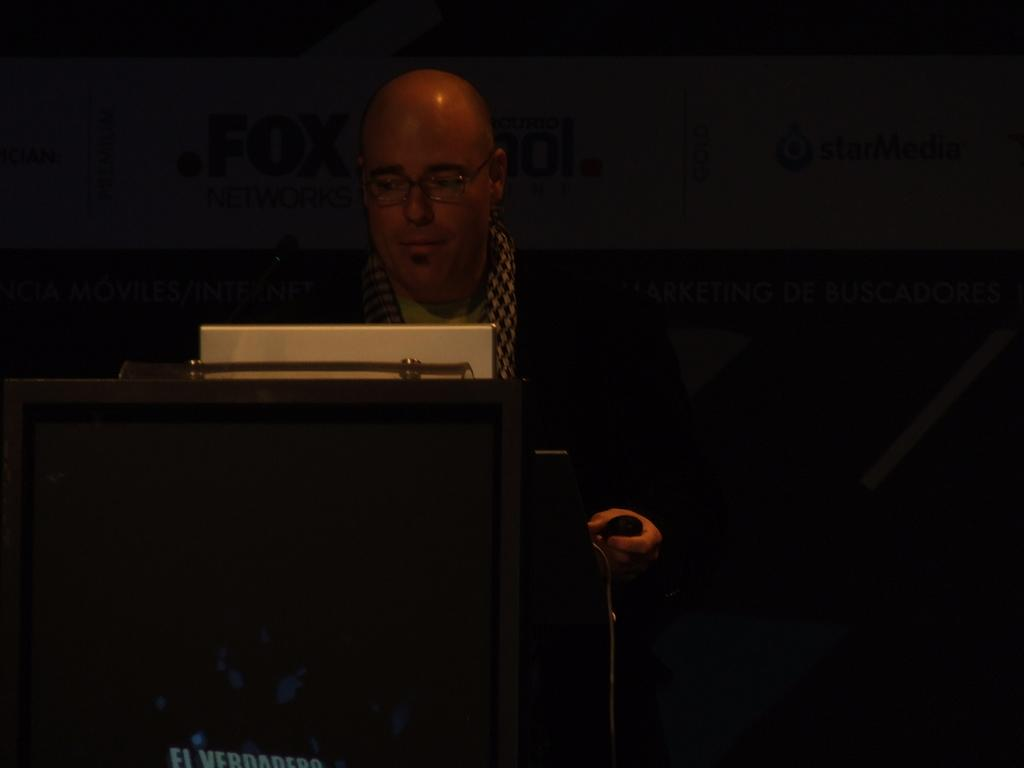What can be seen on the person's face in the image? There is a person with eyeglasses in the image. What is located in front of the person? There is an object in front of the person. What can be seen on the board in the background of the image? There is written text on a board in the background of the image. What is at the bottom of the image? There is an object at the bottom of the image. What type of operation is the person performing on the frog in the image? There is no frog or operation present in the image. How many trains can be seen in the image? There are no trains present in the image. 